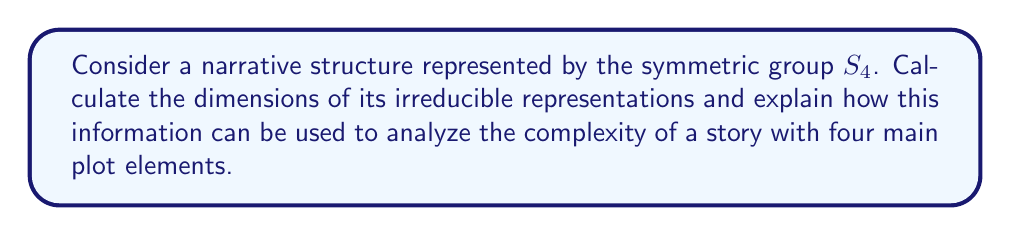Can you solve this math problem? To analyze the narrative complexity using representation theory, we'll follow these steps:

1) First, recall that the irreducible representations of $S_n$ correspond to partitions of $n$. For $S_4$, we have five partitions:
   $[4], [3,1], [2,2], [2,1,1], [1,1,1,1]$

2) To calculate the dimensions of these representations, we can use the hook length formula:
   $$\dim(\lambda) = \frac{n!}{\prod_{(i,j)\in\lambda} h(i,j)}$$
   where $h(i,j)$ is the hook length of the cell $(i,j)$ in the Young diagram.

3) Let's calculate for each partition:

   $[4]$: $$\dim([4]) = \frac{4!}{4 \cdot 3 \cdot 2 \cdot 1} = 1$$

   $[3,1]$: $$\dim([3,1]) = \frac{4!}{4 \cdot 2 \cdot 1 \cdot 1} = 3$$

   $[2,2]$: $$\dim([2,2]) = \frac{4!}{3 \cdot 2 \cdot 2 \cdot 1} = 2$$

   $[2,1,1]$: $$\dim([2,1,1]) = \frac{4!}{3 \cdot 1 \cdot 1 \cdot 1} = 3$$

   $[1,1,1,1]$: $$\dim([1,1,1,1]) = \frac{4!}{4 \cdot 3 \cdot 2 \cdot 1} = 1$$

4) These dimensions represent different ways the four plot elements can interact:
   - Dim 1: Completely symmetric (all elements treated equally) or completely antisymmetric
   - Dim 2: Paired interactions
   - Dim 3: Three elements interacting with one separate, or one dominant element with three subordinates

5) Higher dimensional representations suggest more complex interactions between plot elements. The presence of 3-dimensional representations indicates a moderate level of complexity in the narrative structure.

6) The distribution of dimensions (1, 3, 2, 3, 1) provides a fingerprint of the narrative's structural complexity. This can be visualized to aid in understanding the story's structure.
Answer: Dimensions: 1, 3, 2, 3, 1 